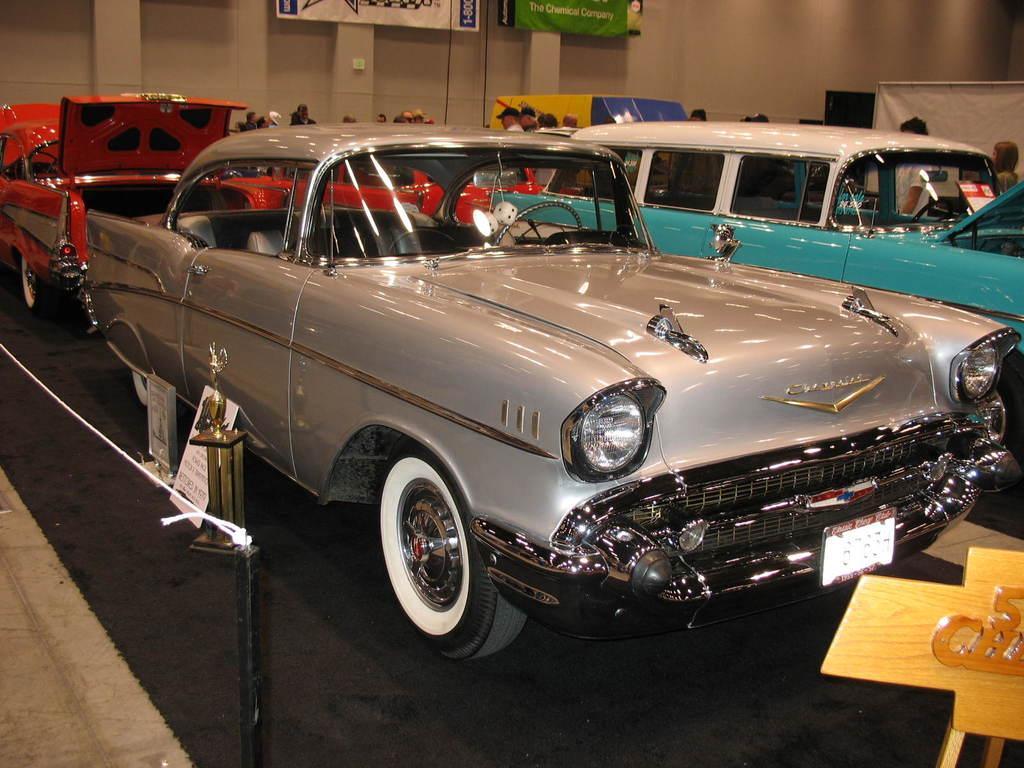How would you summarize this image in a sentence or two? In this image I can see cars. There is a board on the right and a rope fence on the left. People are standing at the back and there are banners. 